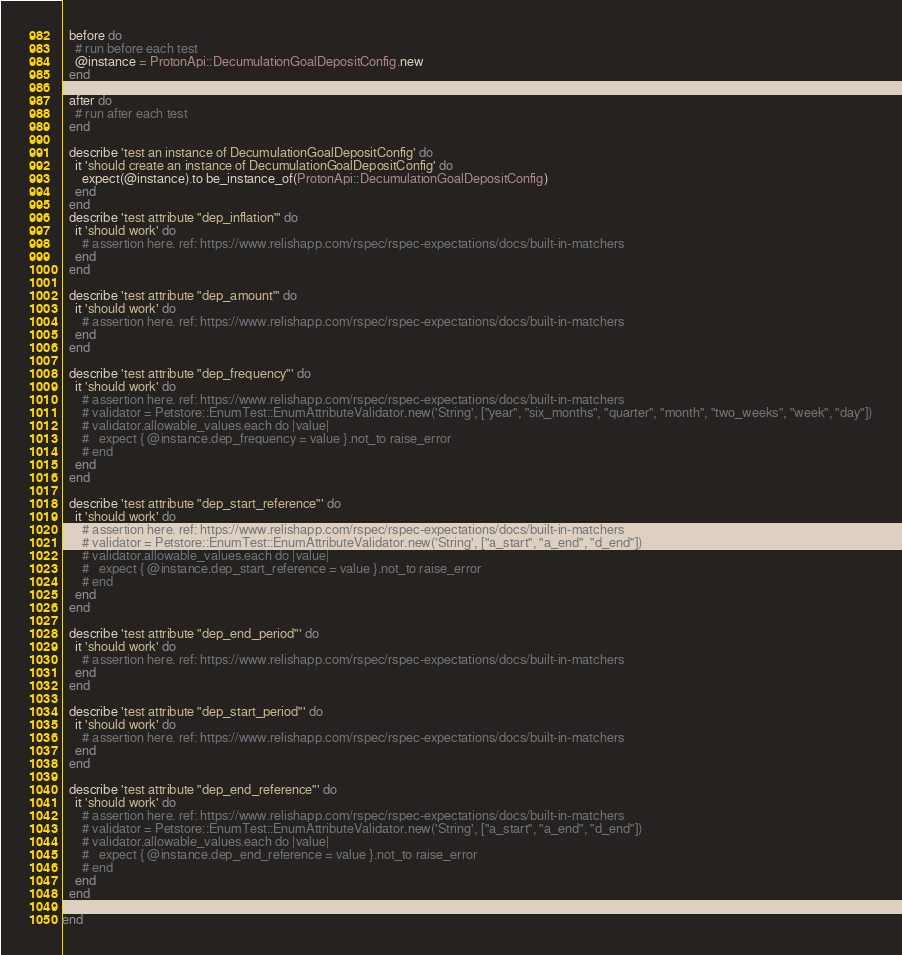Convert code to text. <code><loc_0><loc_0><loc_500><loc_500><_Ruby_>  before do
    # run before each test
    @instance = ProtonApi::DecumulationGoalDepositConfig.new
  end

  after do
    # run after each test
  end

  describe 'test an instance of DecumulationGoalDepositConfig' do
    it 'should create an instance of DecumulationGoalDepositConfig' do
      expect(@instance).to be_instance_of(ProtonApi::DecumulationGoalDepositConfig)
    end
  end
  describe 'test attribute "dep_inflation"' do
    it 'should work' do
      # assertion here. ref: https://www.relishapp.com/rspec/rspec-expectations/docs/built-in-matchers
    end
  end

  describe 'test attribute "dep_amount"' do
    it 'should work' do
      # assertion here. ref: https://www.relishapp.com/rspec/rspec-expectations/docs/built-in-matchers
    end
  end

  describe 'test attribute "dep_frequency"' do
    it 'should work' do
      # assertion here. ref: https://www.relishapp.com/rspec/rspec-expectations/docs/built-in-matchers
      # validator = Petstore::EnumTest::EnumAttributeValidator.new('String', ["year", "six_months", "quarter", "month", "two_weeks", "week", "day"])
      # validator.allowable_values.each do |value|
      #   expect { @instance.dep_frequency = value }.not_to raise_error
      # end
    end
  end

  describe 'test attribute "dep_start_reference"' do
    it 'should work' do
      # assertion here. ref: https://www.relishapp.com/rspec/rspec-expectations/docs/built-in-matchers
      # validator = Petstore::EnumTest::EnumAttributeValidator.new('String', ["a_start", "a_end", "d_end"])
      # validator.allowable_values.each do |value|
      #   expect { @instance.dep_start_reference = value }.not_to raise_error
      # end
    end
  end

  describe 'test attribute "dep_end_period"' do
    it 'should work' do
      # assertion here. ref: https://www.relishapp.com/rspec/rspec-expectations/docs/built-in-matchers
    end
  end

  describe 'test attribute "dep_start_period"' do
    it 'should work' do
      # assertion here. ref: https://www.relishapp.com/rspec/rspec-expectations/docs/built-in-matchers
    end
  end

  describe 'test attribute "dep_end_reference"' do
    it 'should work' do
      # assertion here. ref: https://www.relishapp.com/rspec/rspec-expectations/docs/built-in-matchers
      # validator = Petstore::EnumTest::EnumAttributeValidator.new('String', ["a_start", "a_end", "d_end"])
      # validator.allowable_values.each do |value|
      #   expect { @instance.dep_end_reference = value }.not_to raise_error
      # end
    end
  end

end
</code> 